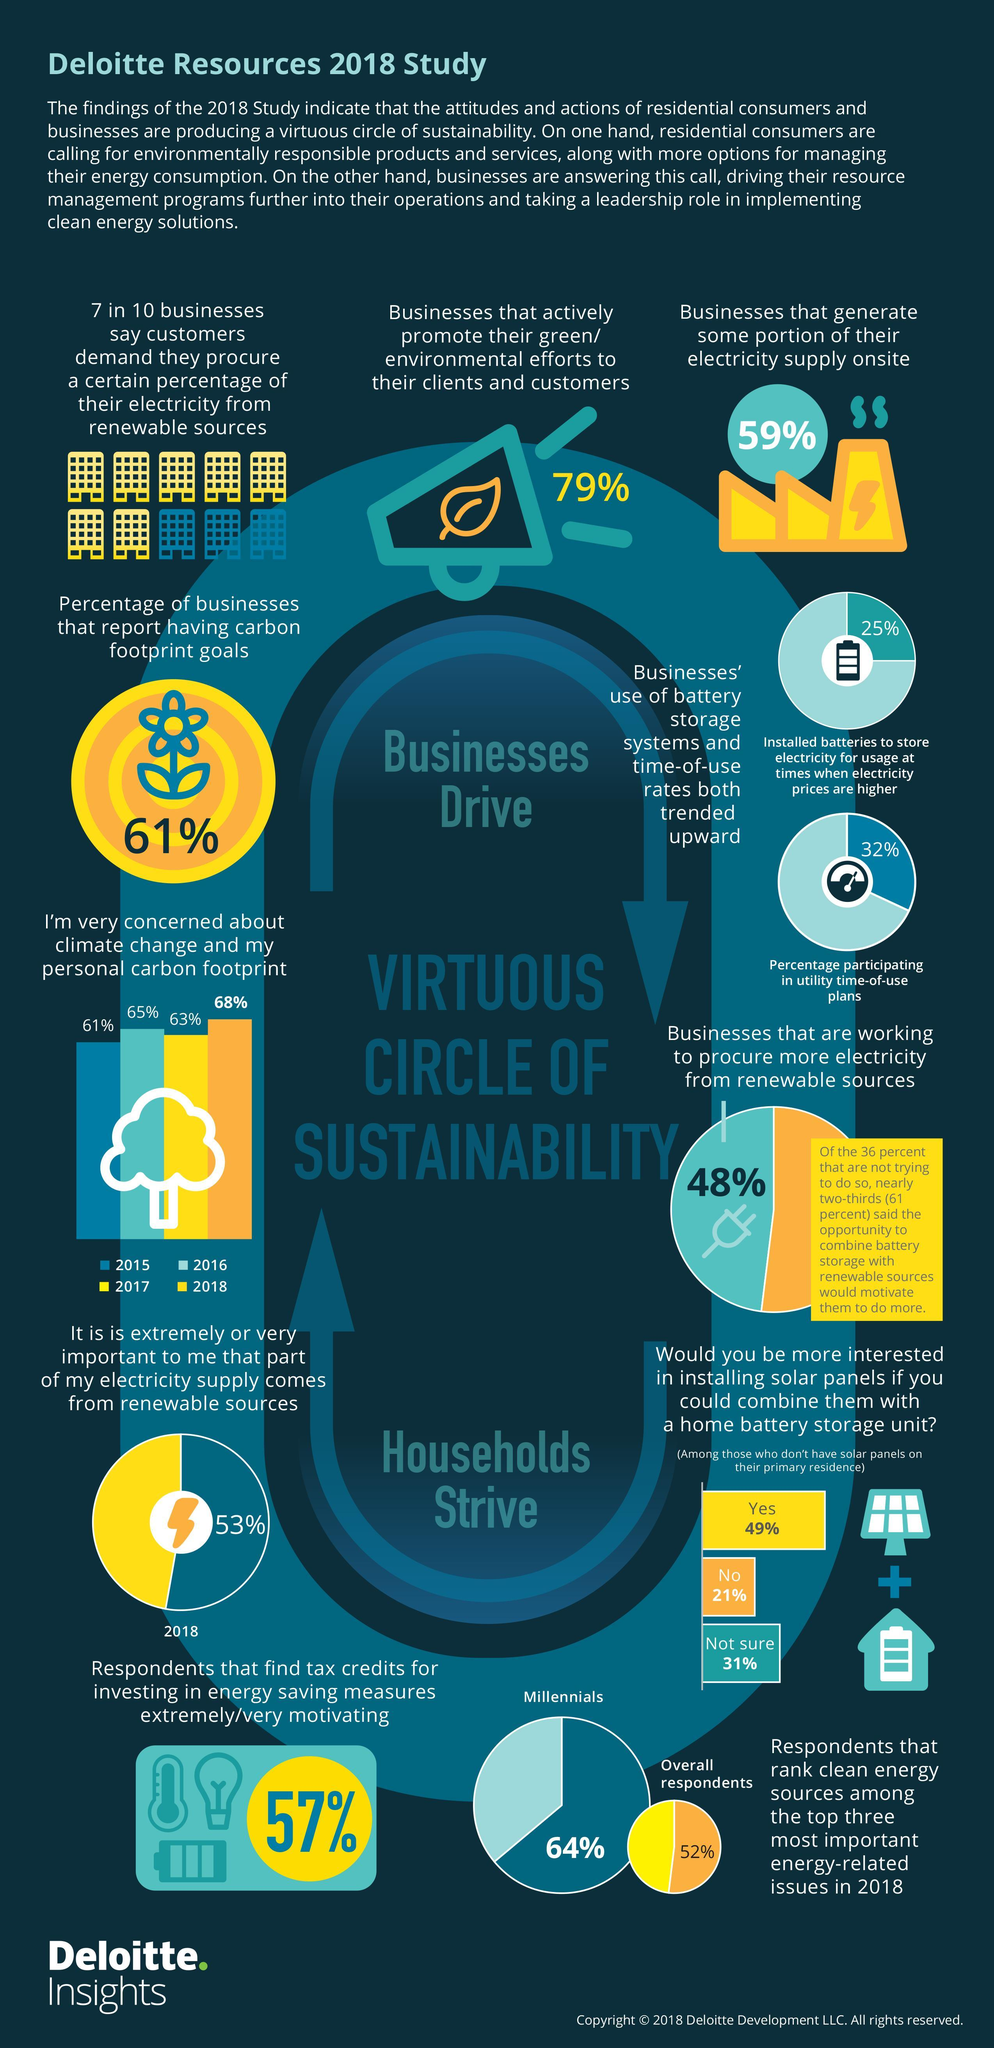What percent of respondents were concerned about the climate change & their carbon foot print in 2017 according to the Deloitte Resources 2018 study?
Answer the question with a short phrase. 63% What percent of businesses generate some portion of their electricity supply onsite as per the Deloitte Resources 2018 study? 59% What percent of respondents were concerned about the climate change & their carbon foot print in 2016 according to the Deloitte Resources 2018 study? 65% What percentage of businesses report that they have carbon footprint goals according to the Deloitte Resources 2018 study? 61% What percent of businesses actively promote their environmental efforts to their clients & customers according to the Deloitte Resources 2018 study? 79% What percent of respondents find that tax credits for investing in energy saving measures are extremely motivating according to the Deloitte Resources 2018 study? 57% 